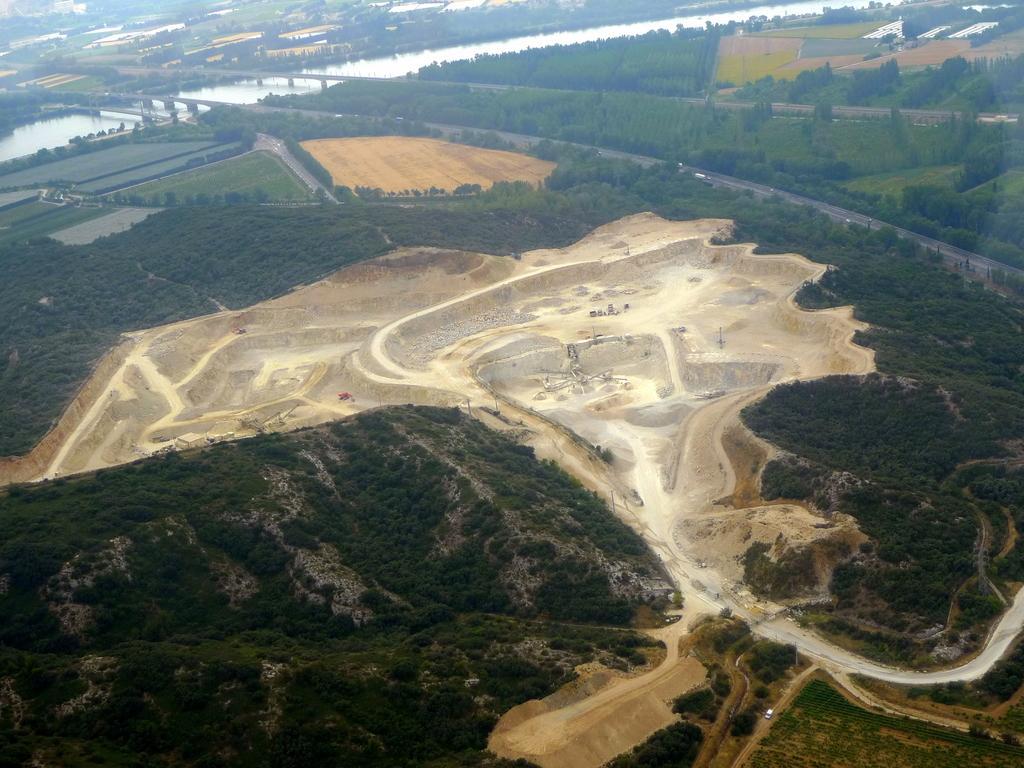How would you summarize this image in a sentence or two? The picture is an aerial view of fields. In the foreground of the picture there are trees and industrial land. In the center of the picture there are trees, fields, bridges and water body. At the top there are fields. 